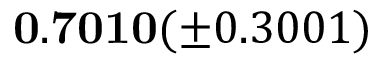Convert formula to latex. <formula><loc_0><loc_0><loc_500><loc_500>0 . 7 0 1 0 ( \pm 0 . 3 0 0 1 )</formula> 